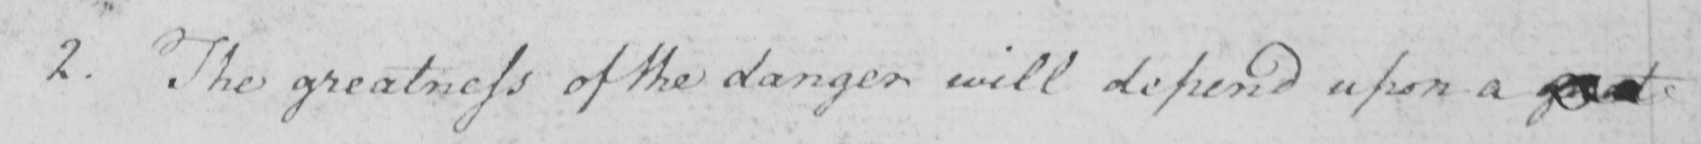Can you tell me what this handwritten text says? 2 . The greatness of the danger will depend upon a great 